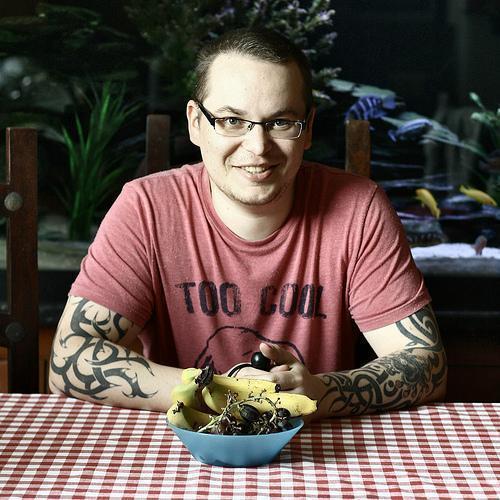What sort of diet might the person at the table have?
Select the accurate response from the four choices given to answer the question.
Options: White food, carnivore, vegan, fasting. Vegan. 